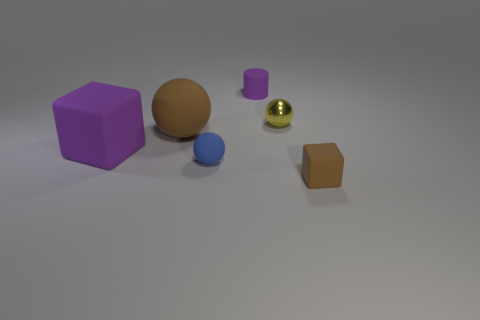There is a cylinder that is the same color as the large rubber cube; what is its size?
Keep it short and to the point. Small. How many objects are either tiny yellow metal cylinders or small yellow objects?
Make the answer very short. 1. How big is the thing behind the tiny metallic sphere?
Provide a succinct answer. Small. Are there any other things that are the same size as the brown matte sphere?
Your answer should be compact. Yes. What color is the tiny matte object that is in front of the yellow thing and on the left side of the yellow sphere?
Your response must be concise. Blue. Does the brown thing that is in front of the large purple thing have the same material as the small blue ball?
Give a very brief answer. Yes. There is a matte cylinder; is it the same color as the small sphere left of the tiny yellow metallic thing?
Provide a short and direct response. No. Are there any cylinders in front of the large ball?
Keep it short and to the point. No. Does the brown object that is on the right side of the brown sphere have the same size as the brown rubber thing left of the rubber cylinder?
Keep it short and to the point. No. Are there any yellow balls of the same size as the yellow shiny thing?
Make the answer very short. No. 